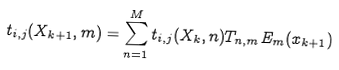Convert formula to latex. <formula><loc_0><loc_0><loc_500><loc_500>t _ { i , j } ( X _ { k + 1 } , m ) = \sum _ { n = 1 } ^ { M } t _ { i , j } ( X _ { k } , n ) T _ { n , m } E _ { m } ( x _ { k + 1 } )</formula> 